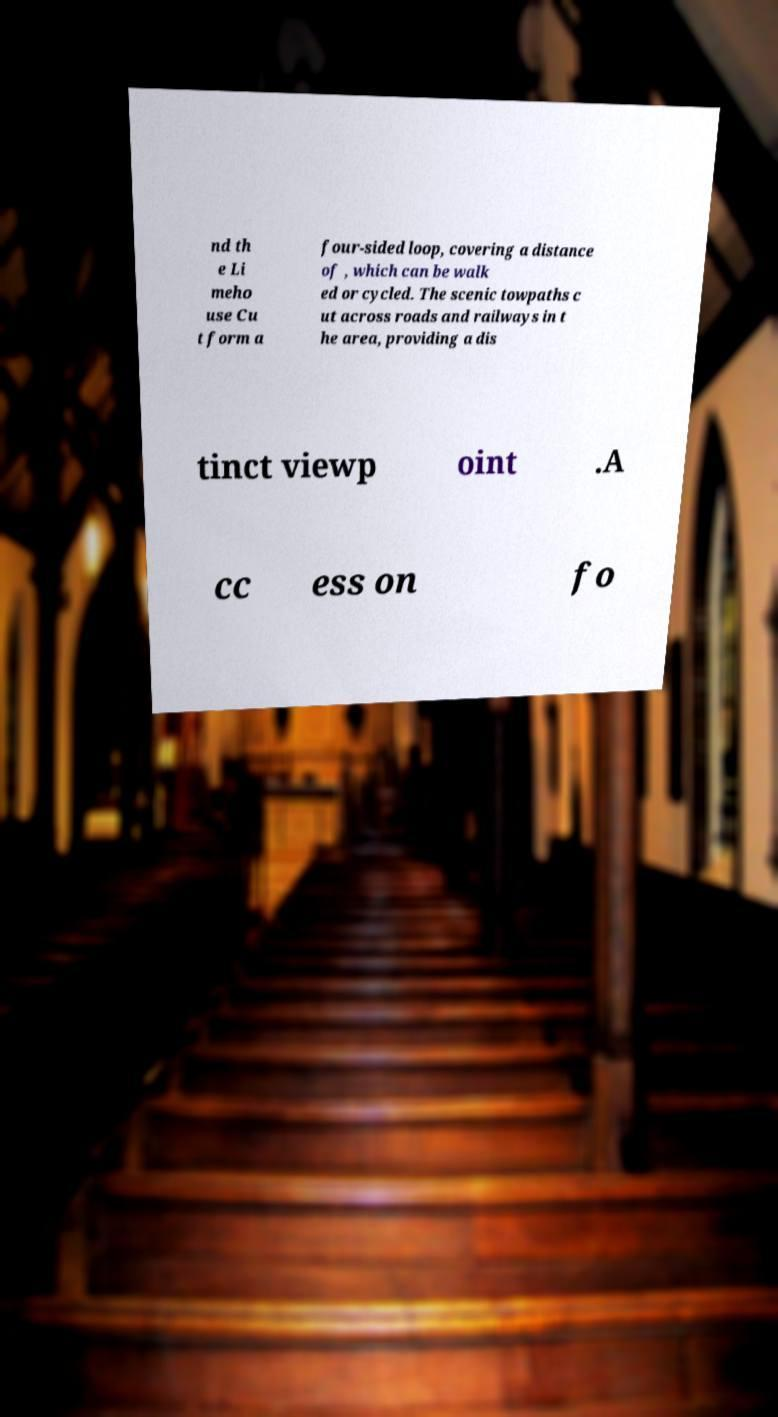For documentation purposes, I need the text within this image transcribed. Could you provide that? nd th e Li meho use Cu t form a four-sided loop, covering a distance of , which can be walk ed or cycled. The scenic towpaths c ut across roads and railways in t he area, providing a dis tinct viewp oint .A cc ess on fo 